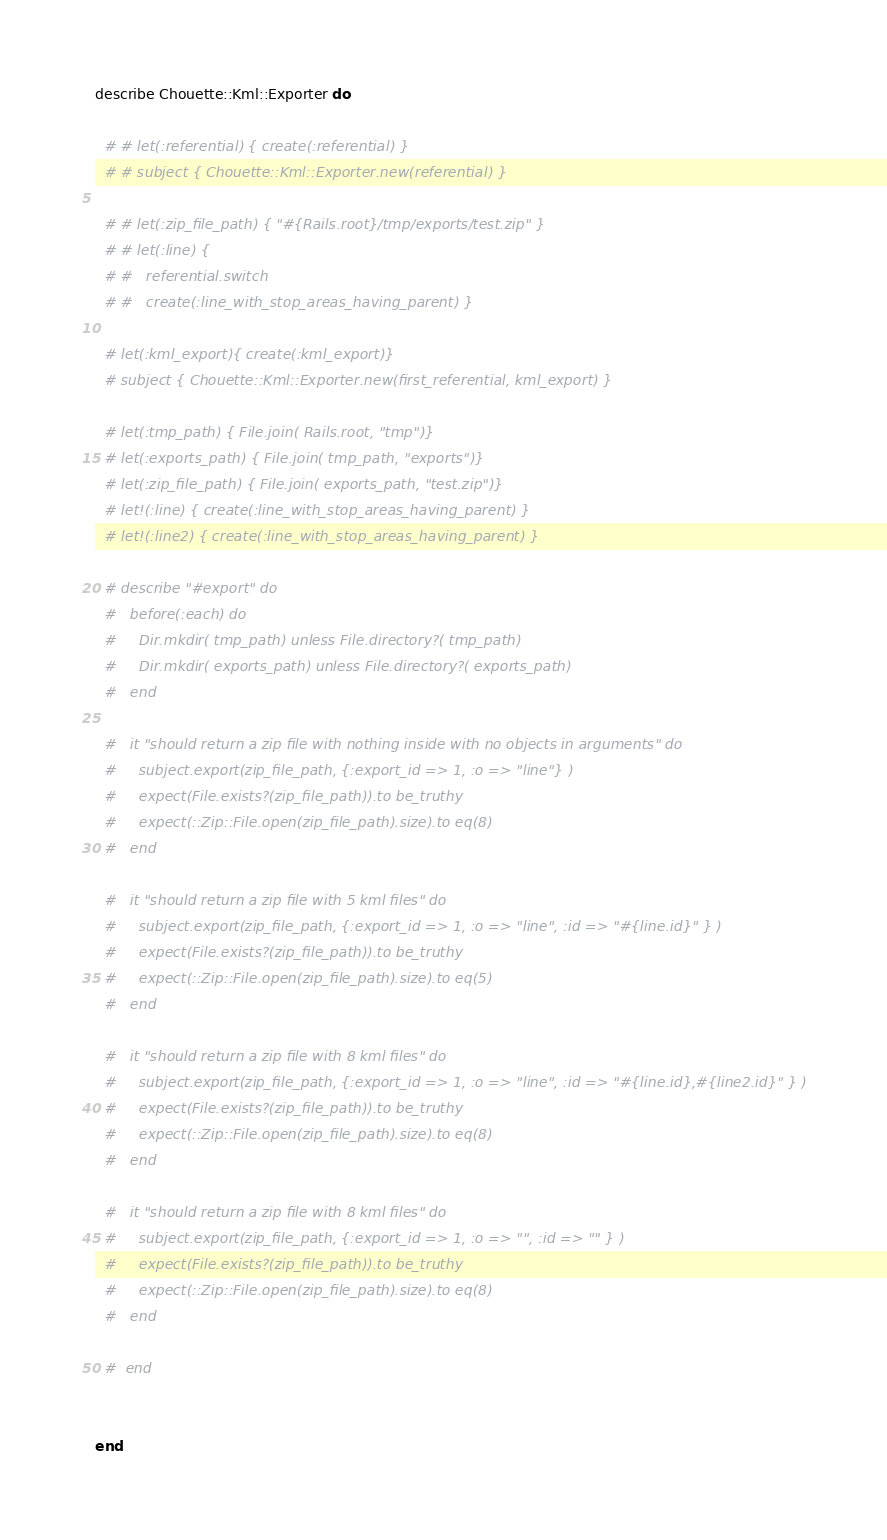<code> <loc_0><loc_0><loc_500><loc_500><_Ruby_>
describe Chouette::Kml::Exporter do

  # # let(:referential) { create(:referential) }
  # # subject { Chouette::Kml::Exporter.new(referential) }

  # # let(:zip_file_path) { "#{Rails.root}/tmp/exports/test.zip" }
  # # let(:line) {
  # #   referential.switch
  # #   create(:line_with_stop_areas_having_parent) }

  # let(:kml_export){ create(:kml_export)}
  # subject { Chouette::Kml::Exporter.new(first_referential, kml_export) }

  # let(:tmp_path) { File.join( Rails.root, "tmp")}
  # let(:exports_path) { File.join( tmp_path, "exports")}
  # let(:zip_file_path) { File.join( exports_path, "test.zip")}
  # let!(:line) { create(:line_with_stop_areas_having_parent) }
  # let!(:line2) { create(:line_with_stop_areas_having_parent) }

  # describe "#export" do
  #   before(:each) do
  #     Dir.mkdir( tmp_path) unless File.directory?( tmp_path)
  #     Dir.mkdir( exports_path) unless File.directory?( exports_path)
  #   end

  #   it "should return a zip file with nothing inside with no objects in arguments" do
  #     subject.export(zip_file_path, {:export_id => 1, :o => "line"} )
  #     expect(File.exists?(zip_file_path)).to be_truthy
  #     expect(::Zip::File.open(zip_file_path).size).to eq(8)
  #   end

  #   it "should return a zip file with 5 kml files" do
  #     subject.export(zip_file_path, {:export_id => 1, :o => "line", :id => "#{line.id}" } )
  #     expect(File.exists?(zip_file_path)).to be_truthy
  #     expect(::Zip::File.open(zip_file_path).size).to eq(5)
  #   end

  #   it "should return a zip file with 8 kml files" do
  #     subject.export(zip_file_path, {:export_id => 1, :o => "line", :id => "#{line.id},#{line2.id}" } )
  #     expect(File.exists?(zip_file_path)).to be_truthy
  #     expect(::Zip::File.open(zip_file_path).size).to eq(8)
  #   end

  #   it "should return a zip file with 8 kml files" do
  #     subject.export(zip_file_path, {:export_id => 1, :o => "", :id => "" } )
  #     expect(File.exists?(zip_file_path)).to be_truthy
  #     expect(::Zip::File.open(zip_file_path).size).to eq(8)
  #   end

  #  end


end
</code> 